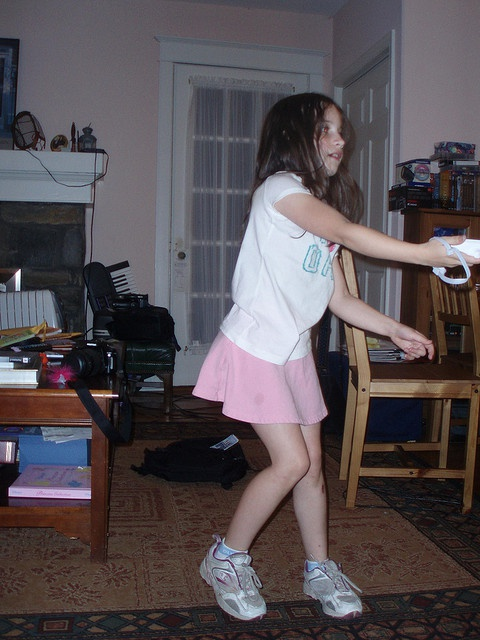Describe the objects in this image and their specific colors. I can see people in gray, darkgray, lavender, and black tones, chair in gray, black, and maroon tones, dining table in gray, maroon, and black tones, backpack in gray, black, darkblue, and purple tones, and chair in gray, black, and maroon tones in this image. 